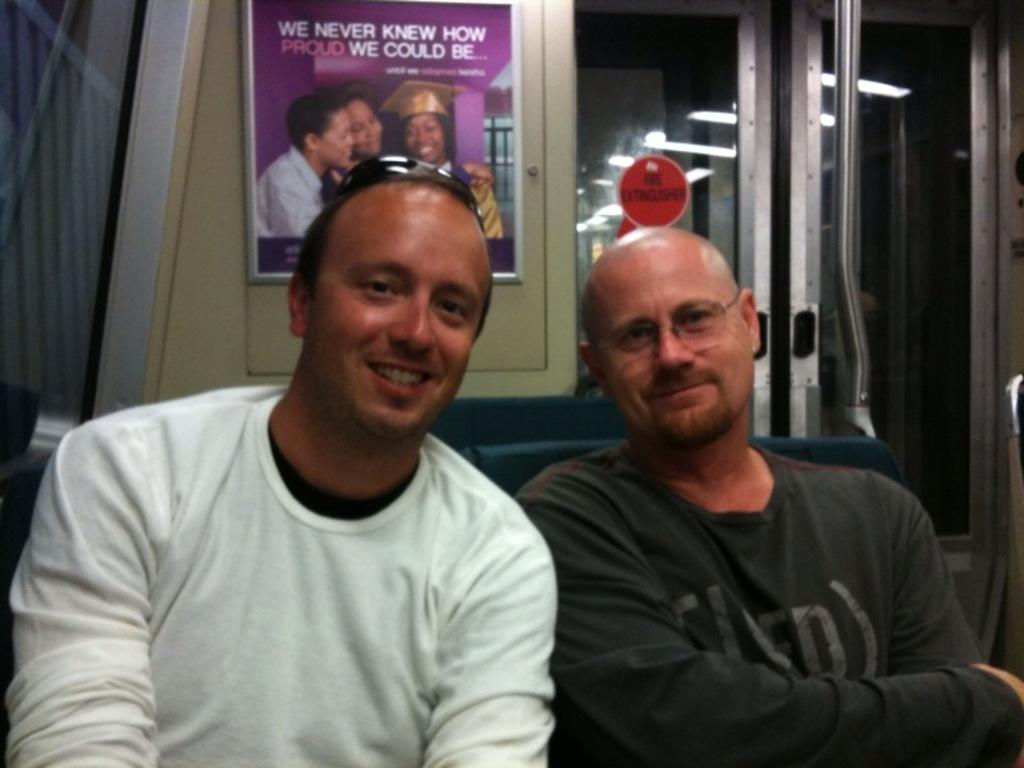How many people are in the image? There are two men in the image. What are the men doing in the image? The men are sitting. What can be seen in the background of the image? There is a poster and a glass door in the background of the image. What type of seed is being planted by the men in the image? There is no seed or planting activity depicted in the image; the men are simply sitting. 